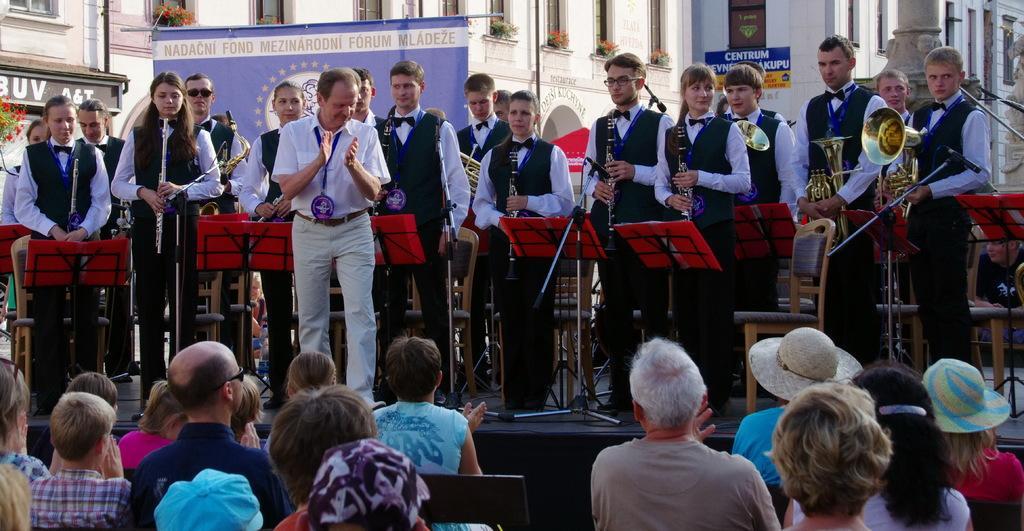Please provide a concise description of this image. In this picture we can see a group of people where some are sitting on chairs and some are standing on stage and holding musical instruments with their hands, stands, mics and in the background we can see banners, buildings with windows, plants. 